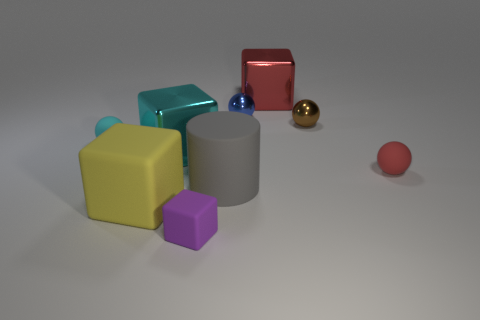What is the shape of the big thing that is behind the small cyan thing?
Keep it short and to the point. Cube. What number of other things are made of the same material as the tiny cyan sphere?
Make the answer very short. 4. Does the rubber cylinder have the same color as the small cube?
Your answer should be very brief. No. Is the number of small cyan rubber things that are on the left side of the small cyan ball less than the number of large gray matte objects on the left side of the tiny purple object?
Ensure brevity in your answer.  No. There is another small metallic thing that is the same shape as the blue object; what color is it?
Provide a short and direct response. Brown. Do the sphere that is to the left of the yellow cube and the big cyan thing have the same size?
Keep it short and to the point. No. Is the number of big gray cylinders that are on the right side of the brown object less than the number of small blue matte blocks?
Your answer should be compact. No. Is there anything else that is the same size as the cyan ball?
Provide a short and direct response. Yes. There is a ball that is in front of the small matte sphere to the left of the small red ball; how big is it?
Keep it short and to the point. Small. Is there anything else that is the same shape as the yellow rubber object?
Offer a very short reply. Yes. 